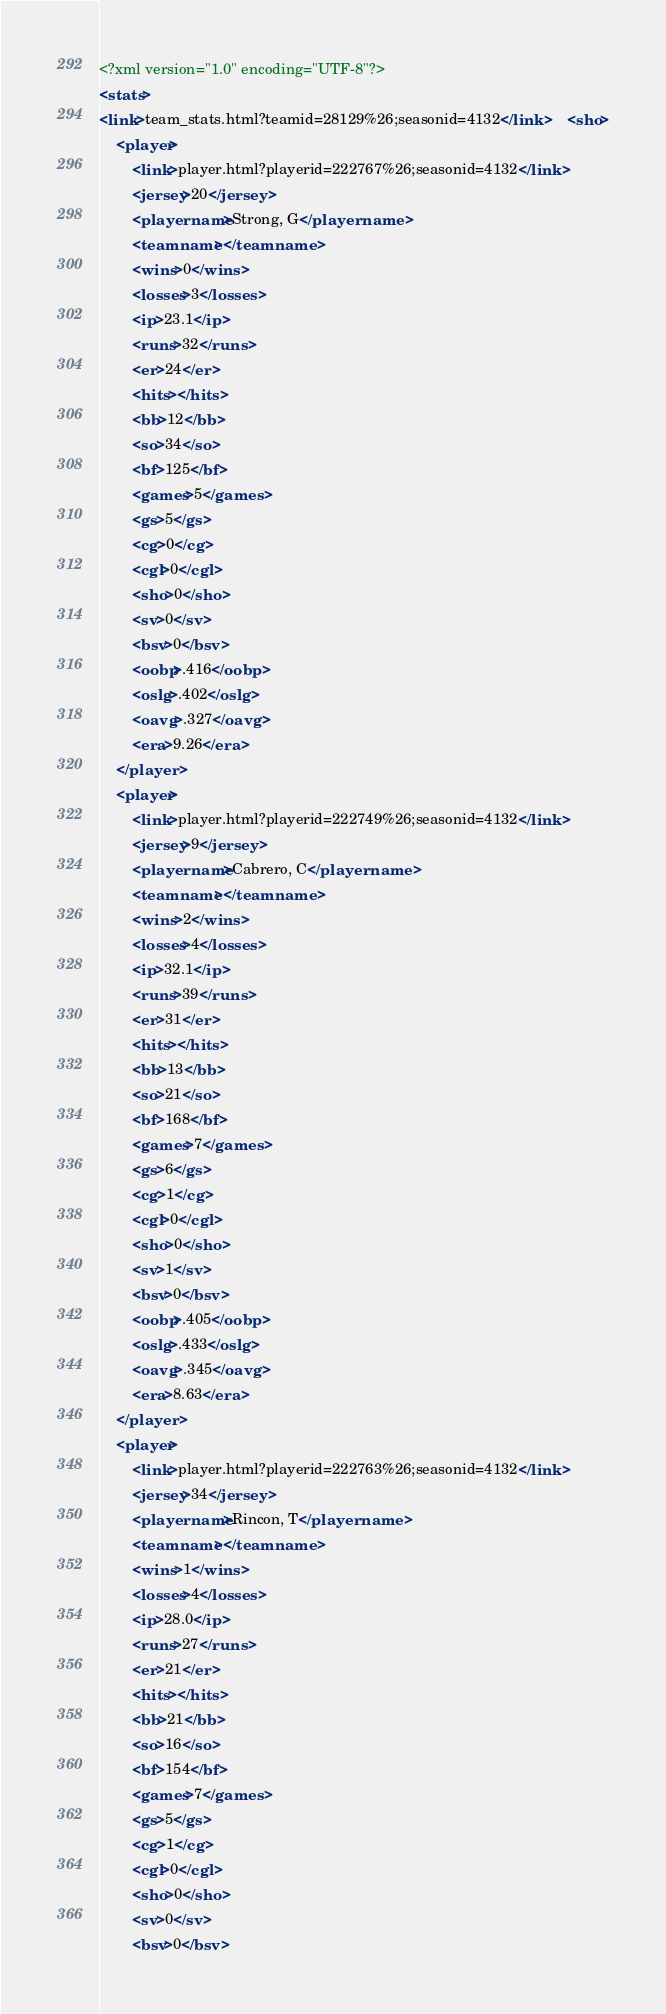Convert code to text. <code><loc_0><loc_0><loc_500><loc_500><_XML_><?xml version="1.0" encoding="UTF-8"?>
<stats>
<link>team_stats.html?teamid=28129%26;seasonid=4132</link>	<sho>
	<player>
		<link>player.html?playerid=222767%26;seasonid=4132</link>
		<jersey>20</jersey>
		<playername>Strong, G</playername>
		<teamname></teamname>
		<wins>0</wins>
		<losses>3</losses>
		<ip>23.1</ip>
		<runs>32</runs>
		<er>24</er>
		<hits></hits>
		<bb>12</bb>
		<so>34</so>
		<bf>125</bf>
		<games>5</games>
		<gs>5</gs>
		<cg>0</cg>
		<cgl>0</cgl>
		<sho>0</sho>
		<sv>0</sv>
		<bsv>0</bsv>
		<oobp>.416</oobp>
		<oslg>.402</oslg>
		<oavg>.327</oavg>
		<era>9.26</era>
	</player>
	<player>
		<link>player.html?playerid=222749%26;seasonid=4132</link>
		<jersey>9</jersey>
		<playername>Cabrero, C</playername>
		<teamname></teamname>
		<wins>2</wins>
		<losses>4</losses>
		<ip>32.1</ip>
		<runs>39</runs>
		<er>31</er>
		<hits></hits>
		<bb>13</bb>
		<so>21</so>
		<bf>168</bf>
		<games>7</games>
		<gs>6</gs>
		<cg>1</cg>
		<cgl>0</cgl>
		<sho>0</sho>
		<sv>1</sv>
		<bsv>0</bsv>
		<oobp>.405</oobp>
		<oslg>.433</oslg>
		<oavg>.345</oavg>
		<era>8.63</era>
	</player>
	<player>
		<link>player.html?playerid=222763%26;seasonid=4132</link>
		<jersey>34</jersey>
		<playername>Rincon, T</playername>
		<teamname></teamname>
		<wins>1</wins>
		<losses>4</losses>
		<ip>28.0</ip>
		<runs>27</runs>
		<er>21</er>
		<hits></hits>
		<bb>21</bb>
		<so>16</so>
		<bf>154</bf>
		<games>7</games>
		<gs>5</gs>
		<cg>1</cg>
		<cgl>0</cgl>
		<sho>0</sho>
		<sv>0</sv>
		<bsv>0</bsv></code> 